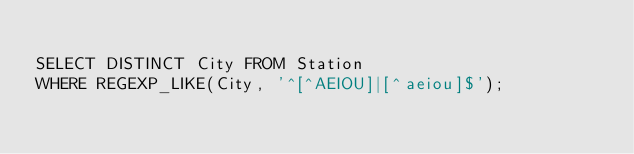Convert code to text. <code><loc_0><loc_0><loc_500><loc_500><_SQL_>
SELECT DISTINCT City FROM Station
WHERE REGEXP_LIKE(City, '^[^AEIOU]|[^aeiou]$');
</code> 